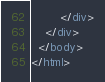Convert code to text. <code><loc_0><loc_0><loc_500><loc_500><_HTML_>		</div>
	</div>
  </body>
</html></code> 